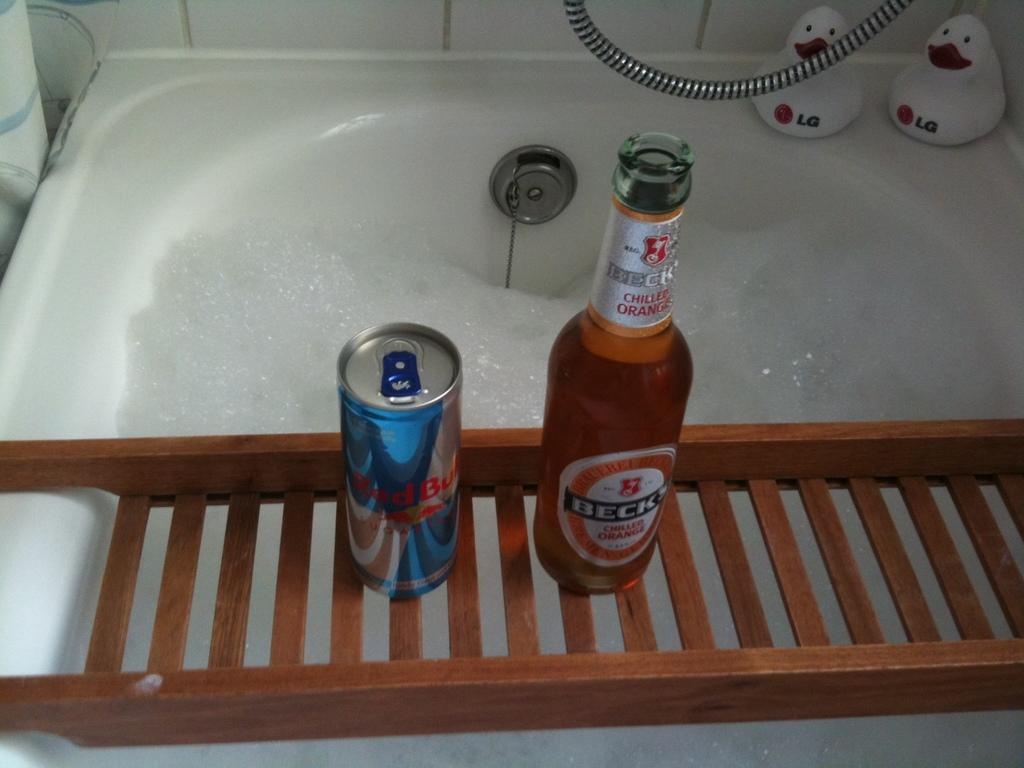What is the name of the glass bottle in the image? The glass bottle is named "beck" in the image. What is the glass bottle placed on? The glass bottle is on a wooden stand. What can be seen beneath the glass bottle? There is a bathing tub filled with foam in the image. How many white toys are present in the image? There are two white toys named "LG" in the image. Where are the white toys located in relation to the bathing tub? The two white toys are behind the bathing tub. What type of steel is used to make the ice in the image? There is no ice present in the image, and therefore no steel is used to make it. 